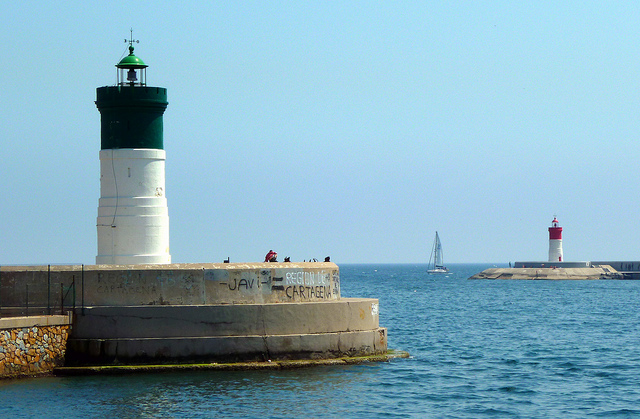Can you tell me what's written on the lighthouse's base? Certainly! There appears to be some graffiti on the lighthouse's base; however, without higher resolution or clarity, it's challenging to read the full message accurately. 